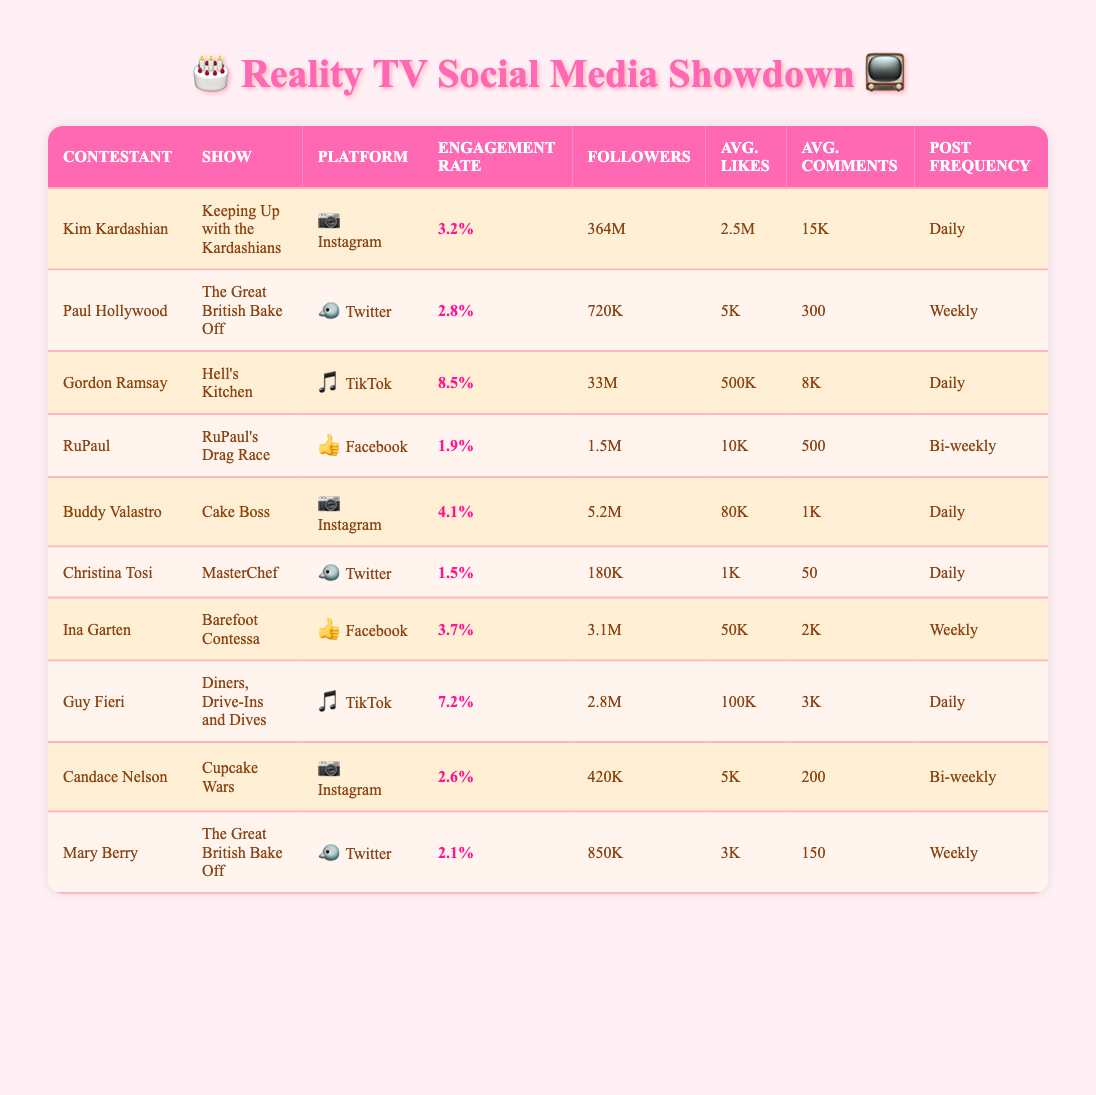What is the engagement rate of Kim Kardashian? The engagement rate for Kim Kardashian is listed directly in the table, which shows her engagement rate as 3.2%.
Answer: 3.2% Which contestant has the highest engagement rate? By looking through the engagement rates listed for each contestant, it is clear that Gordon Ramsay has the highest engagement rate at 8.5%.
Answer: Gordon Ramsay How many more followers does Kim Kardashian have than Buddy Valastro? Kim Kardashian has 364 million followers while Buddy Valastro has 5.2 million. To find the difference, we subtract 5.2 million from 364 million, which gives us 358.8 million followers more.
Answer: 358.8 million Is it true that Paul Hollywood posts more frequently than Christina Tosi? Paul Hollywood's post frequency is listed as weekly, while Christina Tosi posts daily. Since weekly means posting less often than daily, the statement is false.
Answer: No What is the average engagement rate of contestants from the TikTok platform? The engagement rates for TikTok contestants are 8.5% (Gordon Ramsay) and 7.2% (Guy Fieri). To calculate the average, we add these rates (8.5 + 7.2) = 15.7, and then divide by the number of contestants (2), resulting in an average engagement rate of 7.85%.
Answer: 7.85% Which contestant has the lowest average likes? By examining the average likes column, we find that Christina Tosi has the lowest average likes at 1,000.
Answer: Christina Tosi How does the engagement rate of Ina Garten compare to that of RuPaul? Ina Garten has an engagement rate of 3.7%, while RuPaul's rate is 1.9%. Comparing these, we see that Ina Garten's rate is higher than RuPaul's by 1.8%.
Answer: Ina Garten is higher by 1.8% Which platform has the highest average engagement rate among the contestants? The data shows engagement rates per platform for TikTok (7.85%), Instagram (3.3%), Twitter (2.14%), and Facebook (2.4%). The highest average is from TikTok; hence, TikTok has the highest average engagement rate.
Answer: TikTok What is the average follower count of the contestants from the Instagram platform? Looking at the follower counts for Instagram contestants Kim Kardashian (364M), Buddy Valastro (5.2M), and Candace Nelson (420K), we sum them up (364 + 5.2 + 0.42) = 369.62 million, and divide by 3 to find the average, which is approximately 123.21 million.
Answer: 123.21 million 